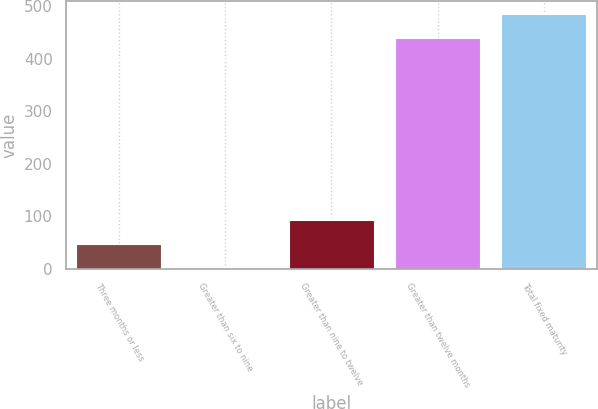Convert chart. <chart><loc_0><loc_0><loc_500><loc_500><bar_chart><fcel>Three months or less<fcel>Greater than six to nine<fcel>Greater than nine to twelve<fcel>Greater than twelve months<fcel>Total fixed maturity<nl><fcel>46.61<fcel>0.1<fcel>93.12<fcel>438.3<fcel>484.81<nl></chart> 